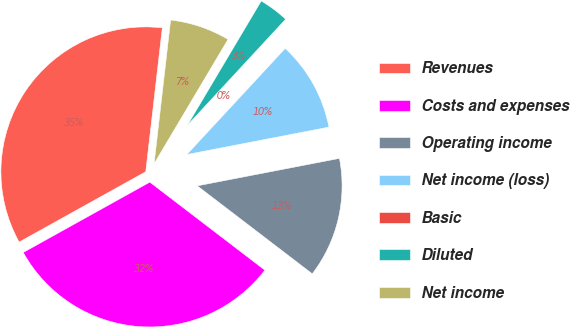<chart> <loc_0><loc_0><loc_500><loc_500><pie_chart><fcel>Revenues<fcel>Costs and expenses<fcel>Operating income<fcel>Net income (loss)<fcel>Basic<fcel>Diluted<fcel>Net income<nl><fcel>34.9%<fcel>31.54%<fcel>13.43%<fcel>10.07%<fcel>0.0%<fcel>3.36%<fcel>6.71%<nl></chart> 